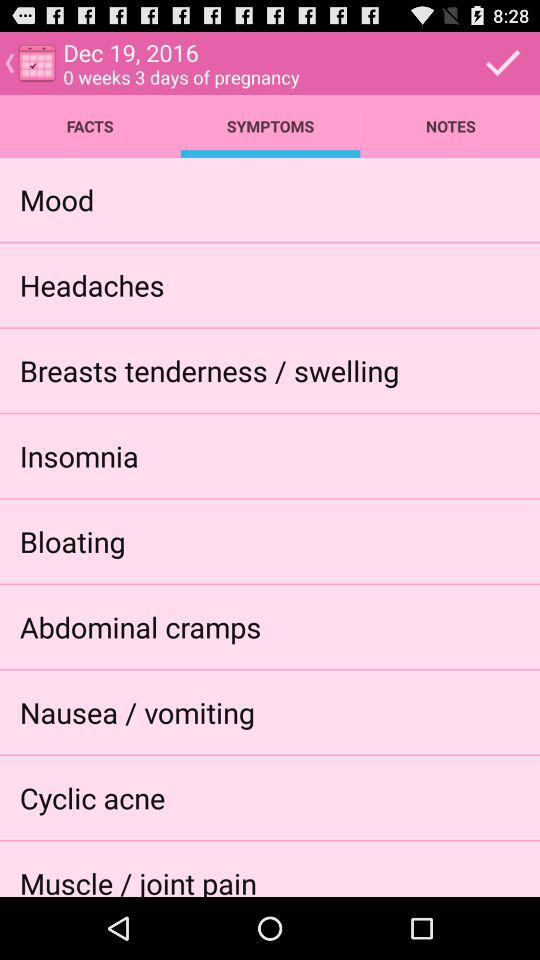How many days of pregnancy have passed? The number of days of pregnancy that have passed is 3. 